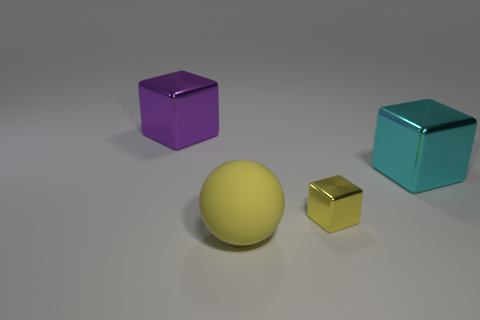Add 1 large yellow spheres. How many objects exist? 5 Subtract all blocks. How many objects are left? 1 Add 1 small metallic cubes. How many small metallic cubes exist? 2 Subtract 0 purple cylinders. How many objects are left? 4 Subtract all cubes. Subtract all tiny cyan metallic balls. How many objects are left? 1 Add 1 purple metal cubes. How many purple metal cubes are left? 2 